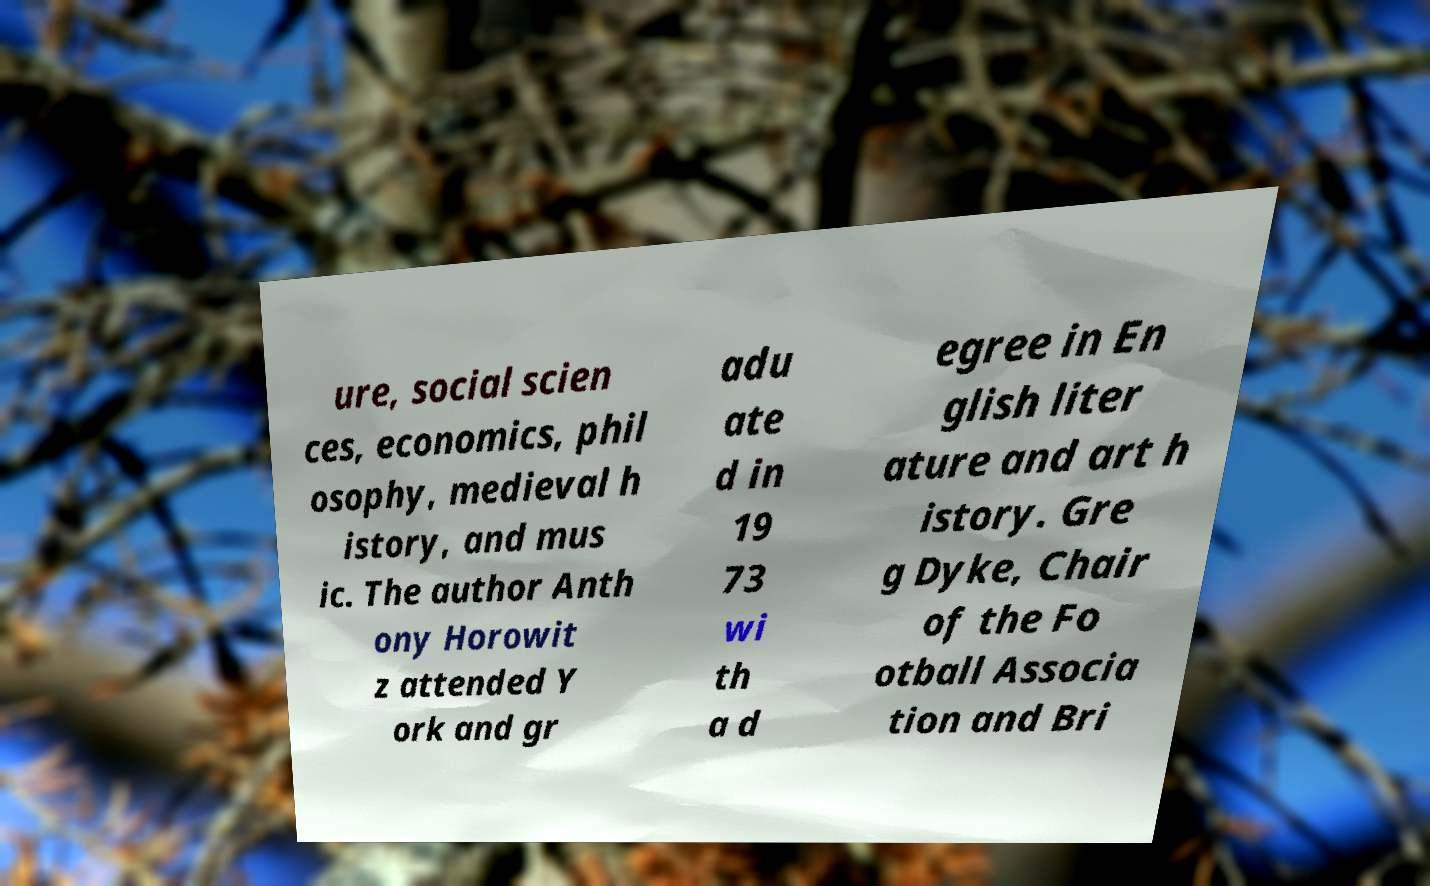Could you extract and type out the text from this image? ure, social scien ces, economics, phil osophy, medieval h istory, and mus ic. The author Anth ony Horowit z attended Y ork and gr adu ate d in 19 73 wi th a d egree in En glish liter ature and art h istory. Gre g Dyke, Chair of the Fo otball Associa tion and Bri 